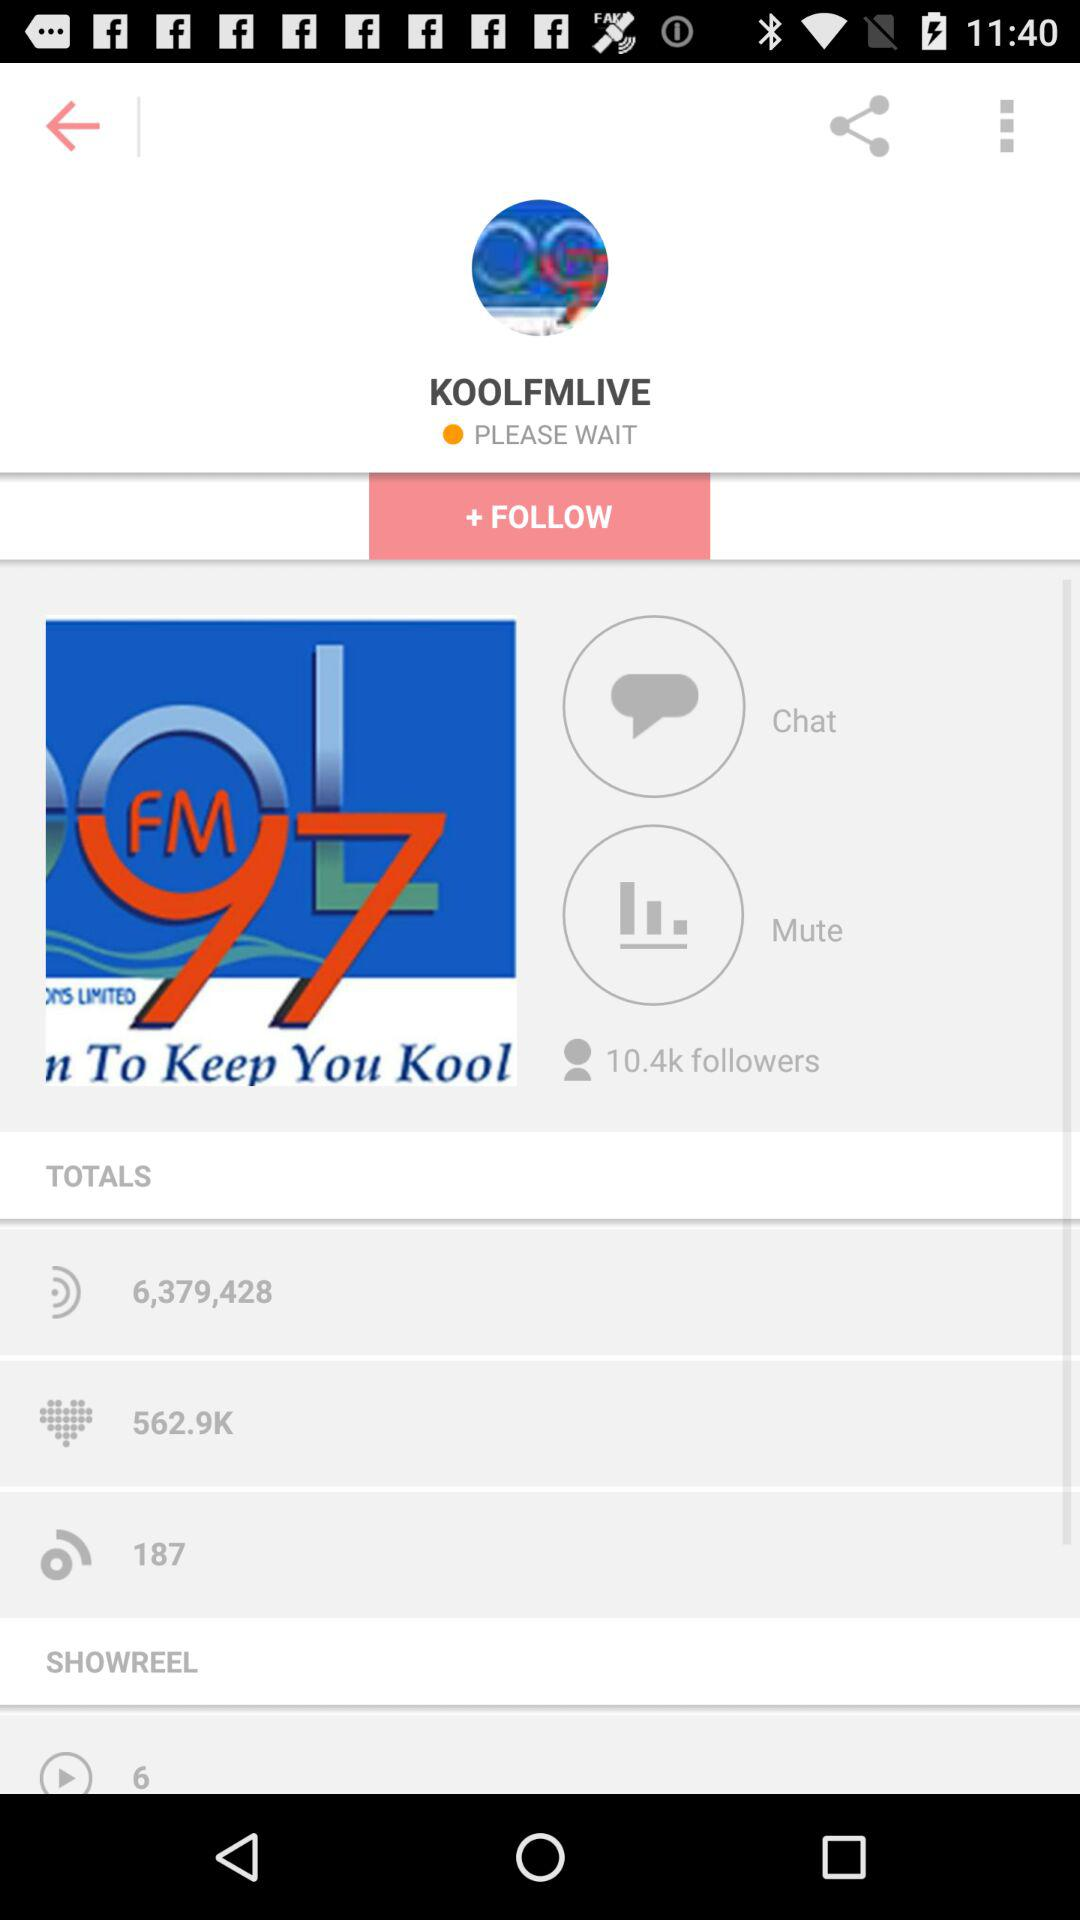How many likes did the account get in total? The account gets 562.9k likes in total. 